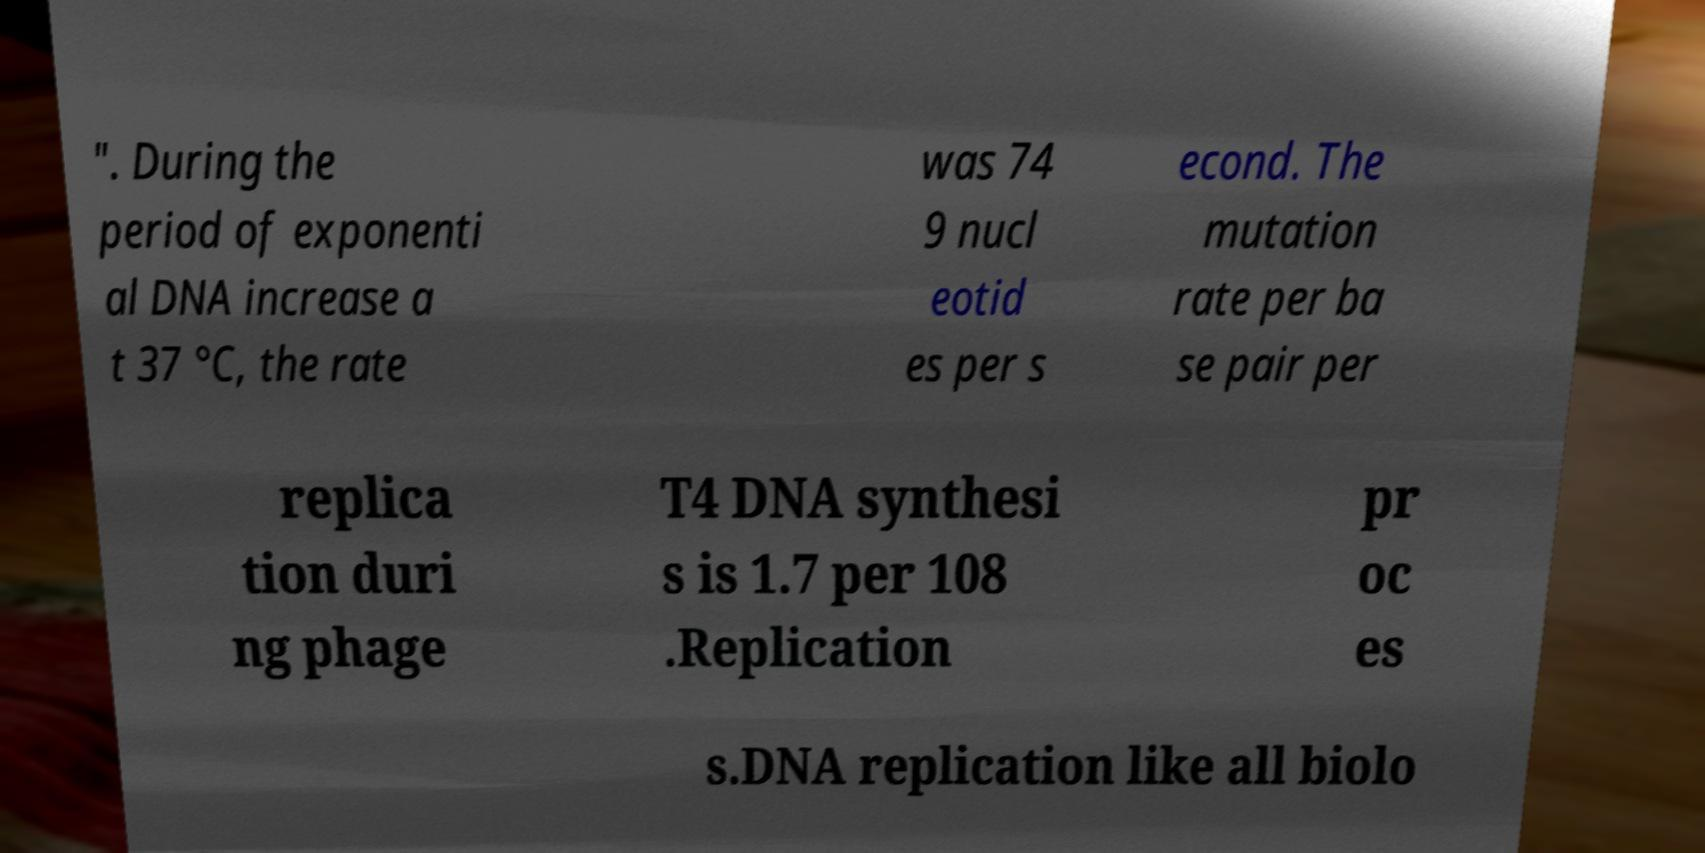Can you read and provide the text displayed in the image?This photo seems to have some interesting text. Can you extract and type it out for me? ". During the period of exponenti al DNA increase a t 37 °C, the rate was 74 9 nucl eotid es per s econd. The mutation rate per ba se pair per replica tion duri ng phage T4 DNA synthesi s is 1.7 per 108 .Replication pr oc es s.DNA replication like all biolo 